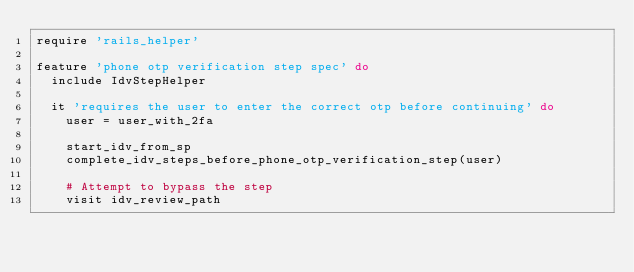<code> <loc_0><loc_0><loc_500><loc_500><_Ruby_>require 'rails_helper'

feature 'phone otp verification step spec' do
  include IdvStepHelper

  it 'requires the user to enter the correct otp before continuing' do
    user = user_with_2fa

    start_idv_from_sp
    complete_idv_steps_before_phone_otp_verification_step(user)

    # Attempt to bypass the step
    visit idv_review_path</code> 